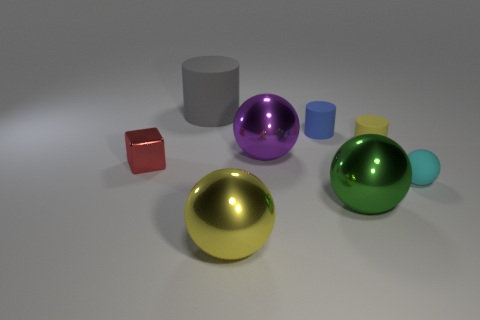Are there more yellow metal objects that are behind the big green metal thing than large rubber cylinders that are to the left of the gray object?
Offer a terse response. No. What number of things are either large blocks or tiny rubber objects?
Provide a short and direct response. 3. There is a yellow shiny thing that is the same size as the gray thing; what is its shape?
Keep it short and to the point. Sphere. The tiny thing that is on the left side of the gray thing is what color?
Ensure brevity in your answer.  Red. How many objects are either tiny matte things that are behind the small cube or small yellow objects that are behind the large yellow metallic object?
Make the answer very short. 2. Do the yellow shiny object and the cyan rubber thing have the same size?
Provide a short and direct response. No. What number of cubes are either tiny things or gray matte things?
Offer a very short reply. 1. How many things are to the right of the big yellow ball and on the left side of the tiny sphere?
Give a very brief answer. 4. Do the cyan rubber ball and the sphere left of the purple object have the same size?
Offer a very short reply. No. Are there any rubber things in front of the big metallic object behind the tiny thing that is left of the blue object?
Provide a succinct answer. Yes. 